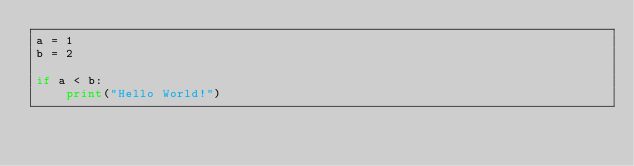Convert code to text. <code><loc_0><loc_0><loc_500><loc_500><_Python_>a = 1
b = 2

if a < b: 
    print("Hello World!")
</code> 